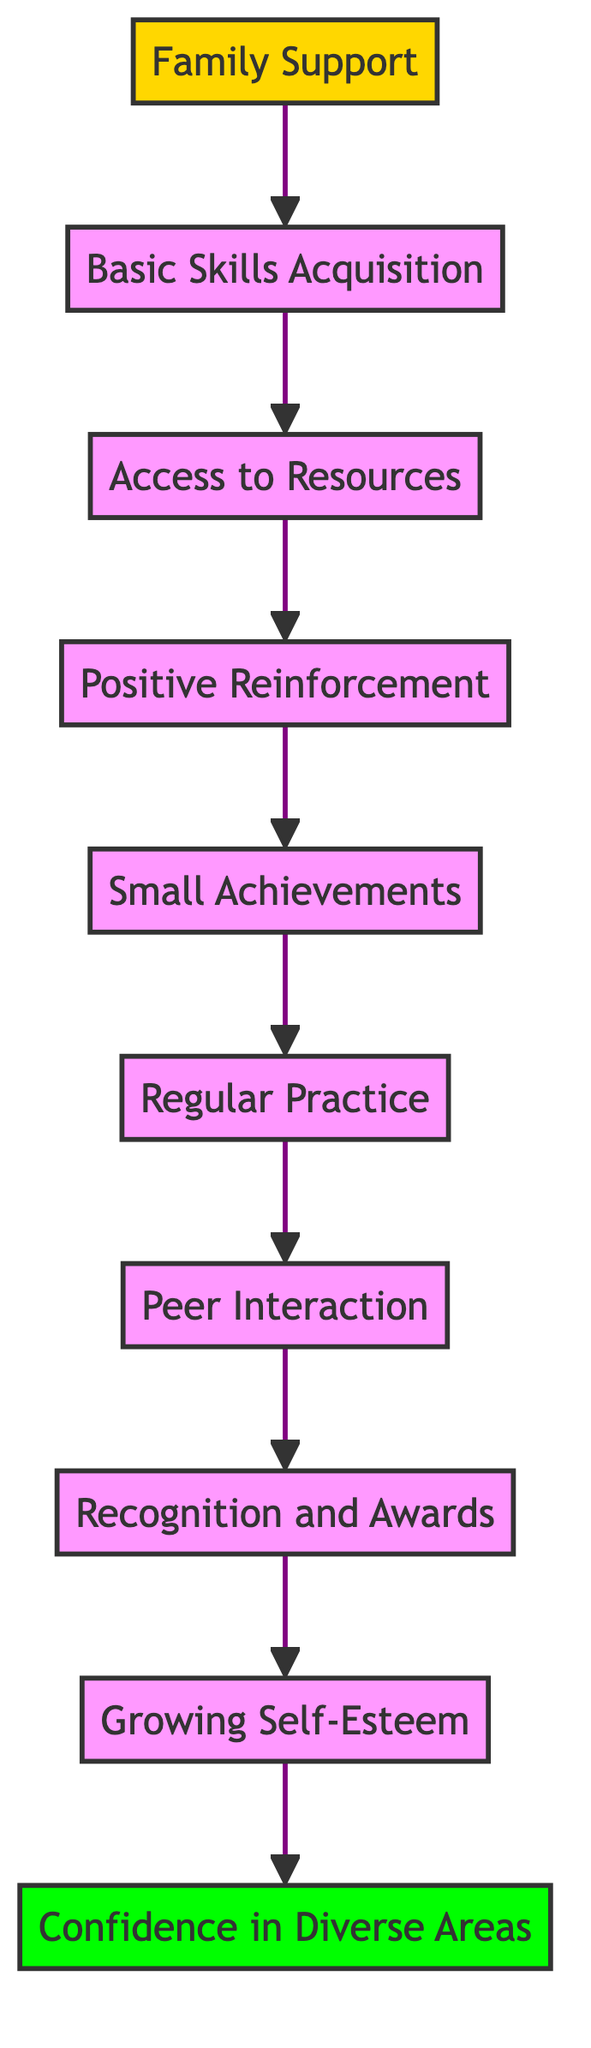What is the first step in gaining confidence through learning? The first step is Family Support, as it represents the foundation for pursuing learning and acquiring new skills.
Answer: Family Support How many levels are there in the flowchart? There are ten levels in the flowchart, starting from Family Support and ending with Confidence in Diverse Areas.
Answer: ten What comes after Basic Skills Acquisition? Access to Resources comes after Basic Skills Acquisition, as it is the next step in the process of gaining confidence.
Answer: Access to Resources What type of reinforcement is mentioned before Small Achievements? Positive Reinforcement is the type of reinforcement mentioned that precedes Small Achievements in the flowchart.
Answer: Positive Reinforcement Which node is directly connected to Peer Interaction? The node directly connected to Peer Interaction is Regular Practice, indicating the flow of learning development.
Answer: Regular Practice What is necessary for Growing Self-Esteem? Regular practice, positive reinforcement, and small achievements are necessary for Growing Self-Esteem, as they contribute to building a positive self-image.
Answer: Regular practice, positive reinforcement, and small achievements What does Recognition and Awards lead to? Recognition and Awards lead to Growing Self-Esteem, as receiving acknowledgments enhances a person’s belief in their abilities.
Answer: Growing Self-Esteem What is the final outcome represented in the flowchart? The final outcome represented in the flowchart is Confidence in Diverse Areas, illustrating the result of the entire learning process.
Answer: Confidence in Diverse Areas 